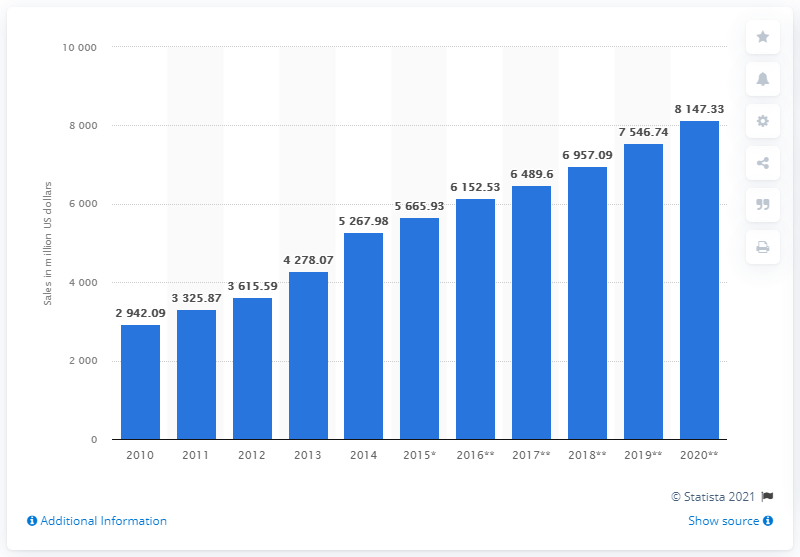Indicate a few pertinent items in this graphic. In 2010, Lidl generated sales of approximately 2942.09 million US dollars. 